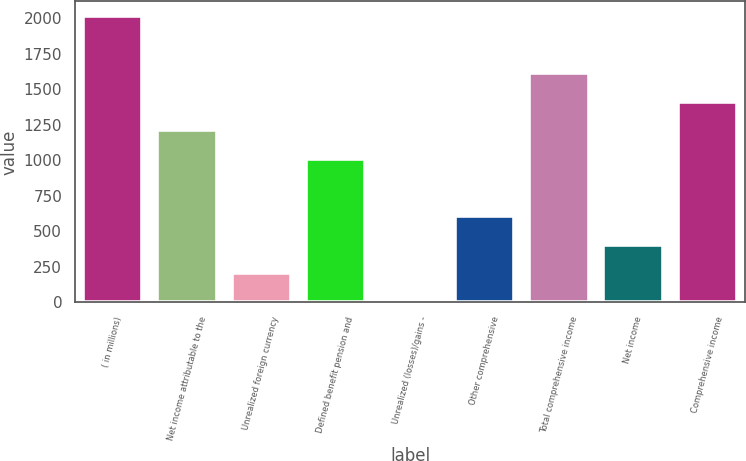<chart> <loc_0><loc_0><loc_500><loc_500><bar_chart><fcel>( in millions)<fcel>Net income attributable to the<fcel>Unrealized foreign currency<fcel>Defined benefit pension and<fcel>Unrealized (losses)/gains -<fcel>Other comprehensive<fcel>Total comprehensive income<fcel>Net income<fcel>Comprehensive income<nl><fcel>2016<fcel>1211.2<fcel>205.2<fcel>1010<fcel>4<fcel>607.6<fcel>1613.6<fcel>406.4<fcel>1412.4<nl></chart> 